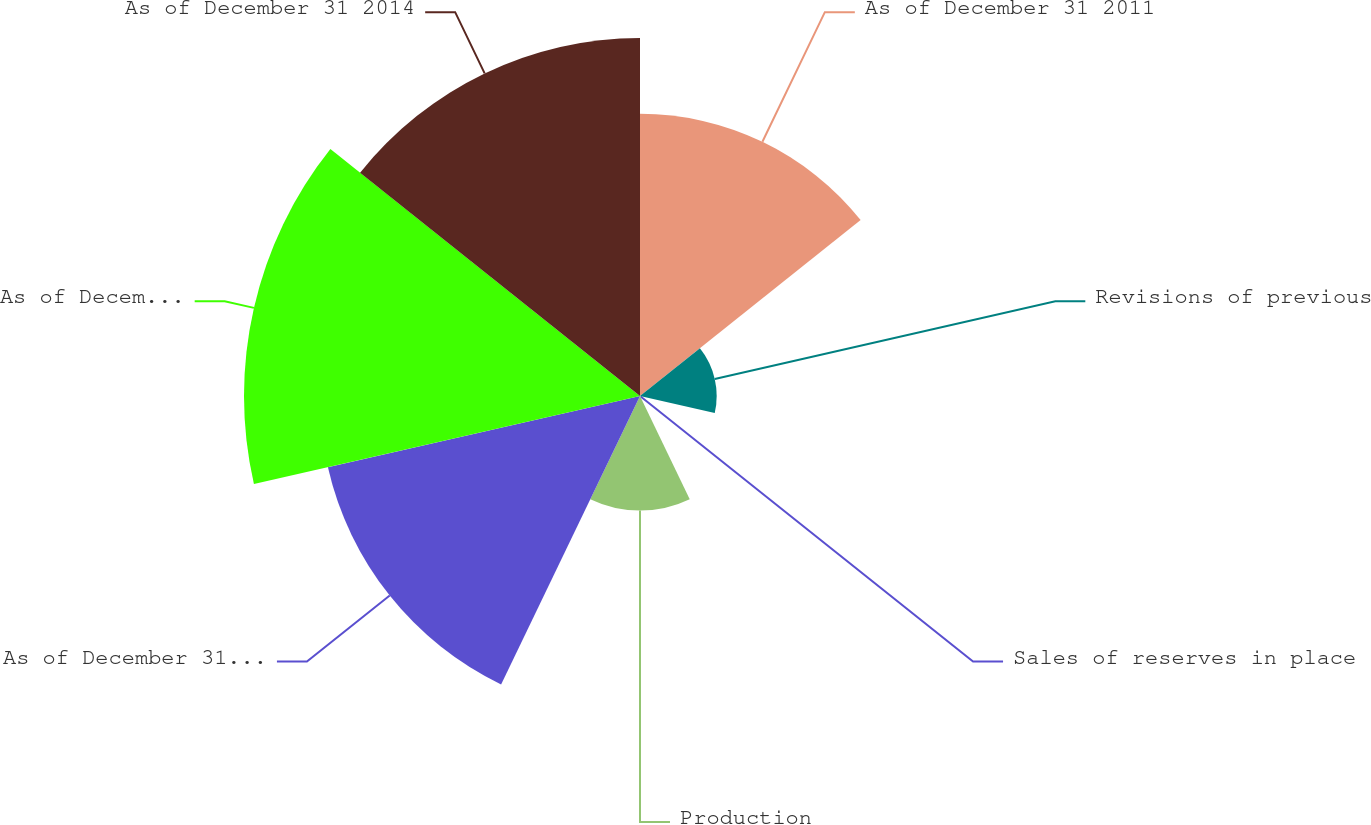<chart> <loc_0><loc_0><loc_500><loc_500><pie_chart><fcel>As of December 31 2011<fcel>Revisions of previous<fcel>Sales of reserves in place<fcel>Production<fcel>As of December 31 2012<fcel>As of December 31 2013<fcel>As of December 31 2014<nl><fcel>18.22%<fcel>4.95%<fcel>0.05%<fcel>7.4%<fcel>20.67%<fcel>25.57%<fcel>23.12%<nl></chart> 